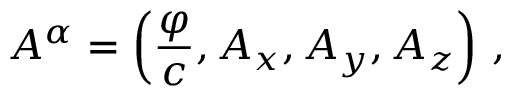Convert formula to latex. <formula><loc_0><loc_0><loc_500><loc_500>A ^ { \alpha } = \left ( { \frac { \varphi } { c } } , A _ { x } , A _ { y } , A _ { z } \right ) \, ,</formula> 